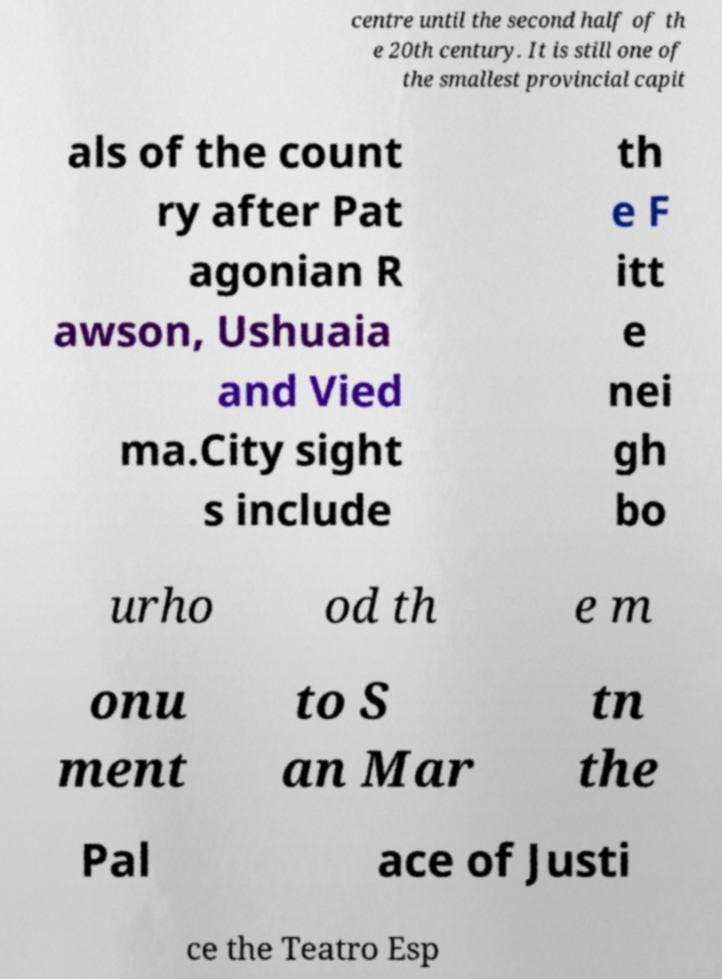There's text embedded in this image that I need extracted. Can you transcribe it verbatim? centre until the second half of th e 20th century. It is still one of the smallest provincial capit als of the count ry after Pat agonian R awson, Ushuaia and Vied ma.City sight s include th e F itt e nei gh bo urho od th e m onu ment to S an Mar tn the Pal ace of Justi ce the Teatro Esp 